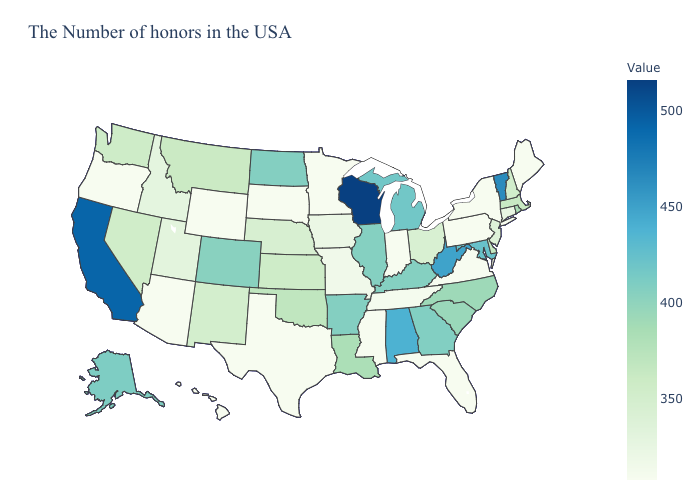Does Utah have the lowest value in the West?
Quick response, please. No. Does Alaska have a lower value than Pennsylvania?
Answer briefly. No. Among the states that border Idaho , does Wyoming have the highest value?
Quick response, please. No. Does Virginia have the highest value in the South?
Give a very brief answer. No. 